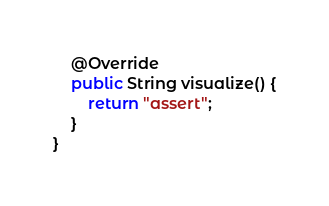<code> <loc_0><loc_0><loc_500><loc_500><_Java_>
    @Override
    public String visualize() {
        return "assert";
    }
}
</code> 